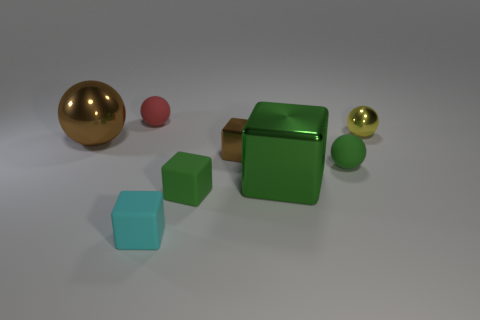Are the tiny yellow ball that is on the right side of the tiny cyan thing and the cyan thing made of the same material?
Offer a very short reply. No. What number of other objects are there of the same size as the red rubber ball?
Your response must be concise. 5. How many large things are either gray matte things or yellow metallic spheres?
Your answer should be very brief. 0. Is the large metallic ball the same color as the tiny metallic cube?
Your answer should be very brief. Yes. Is the number of rubber balls in front of the tiny red matte thing greater than the number of tiny green matte blocks that are behind the brown sphere?
Ensure brevity in your answer.  Yes. There is a metallic cube that is behind the tiny green matte sphere; is it the same color as the large sphere?
Offer a very short reply. Yes. Is there anything else that is the same color as the small shiny cube?
Make the answer very short. Yes. Are there more small objects that are right of the cyan thing than matte blocks?
Ensure brevity in your answer.  Yes. Do the yellow object and the brown ball have the same size?
Provide a succinct answer. No. There is a cyan object that is the same shape as the green metallic thing; what is its material?
Give a very brief answer. Rubber. 